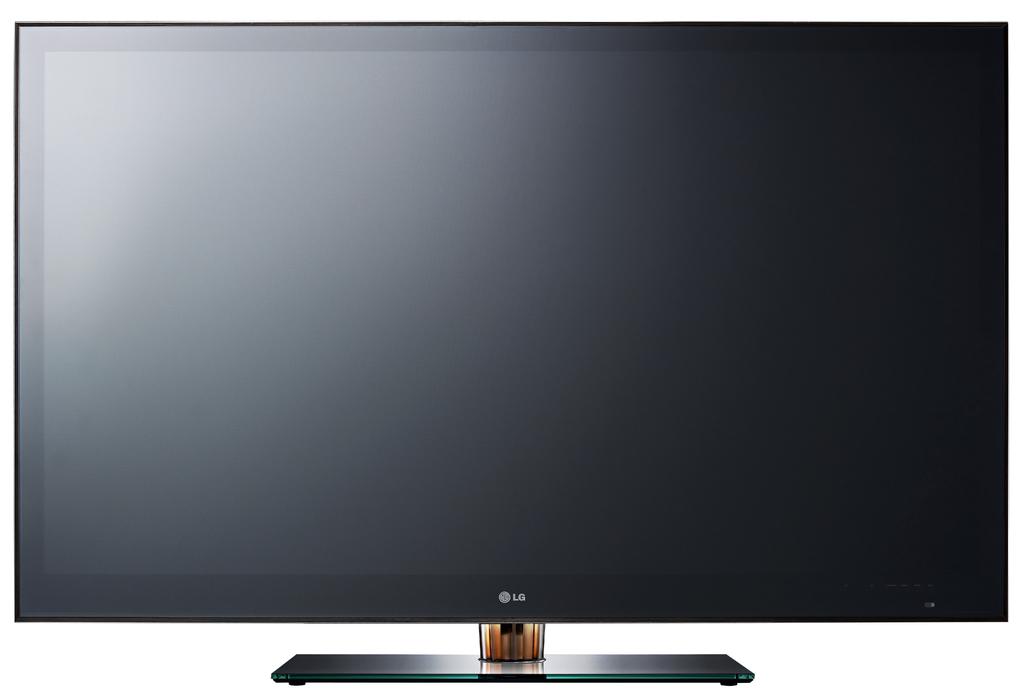What brand tv is this?
Offer a terse response. Lg. Is this a samsung tv?
Your response must be concise. No. 